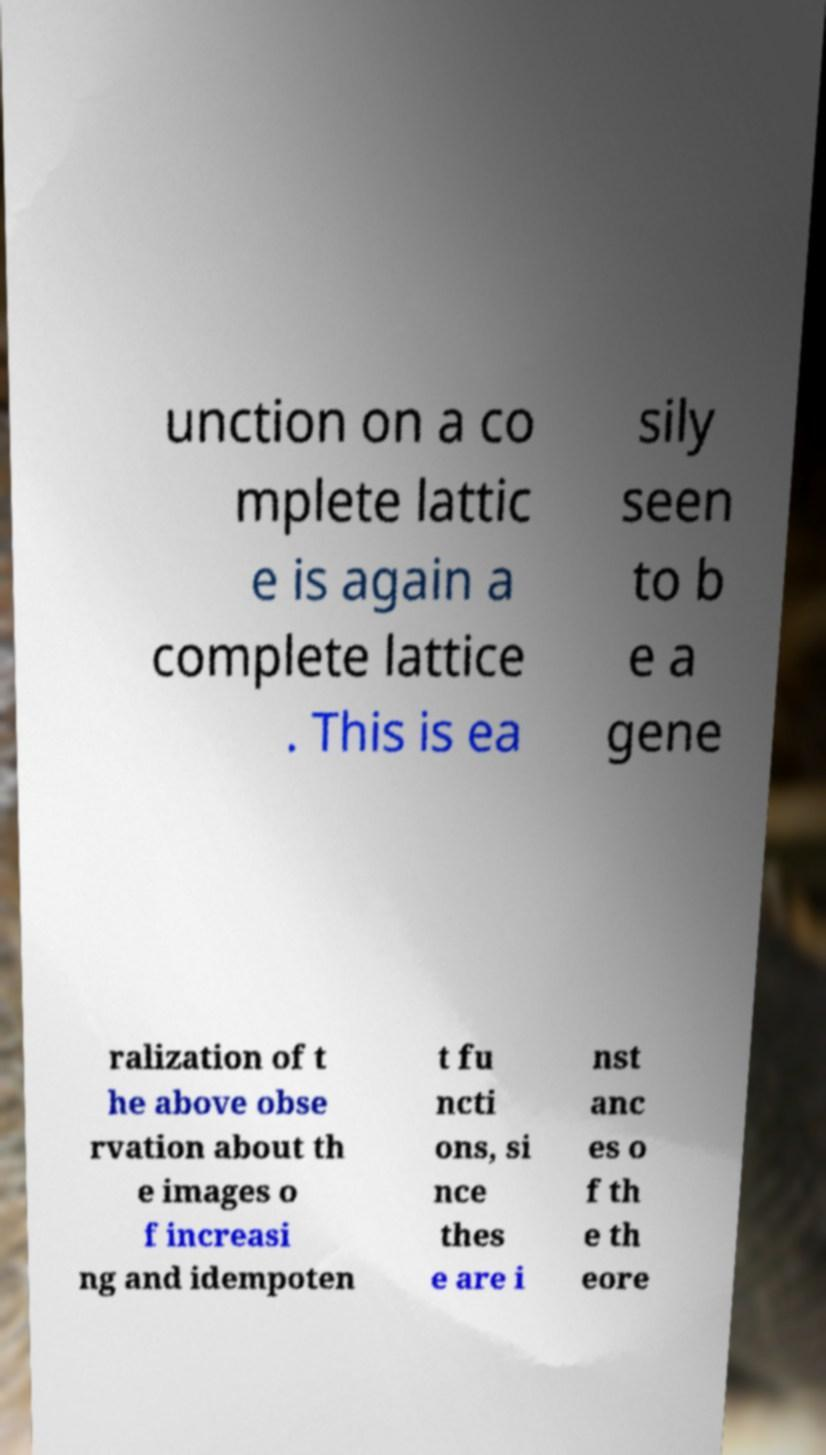Please read and relay the text visible in this image. What does it say? unction on a co mplete lattic e is again a complete lattice . This is ea sily seen to b e a gene ralization of t he above obse rvation about th e images o f increasi ng and idempoten t fu ncti ons, si nce thes e are i nst anc es o f th e th eore 